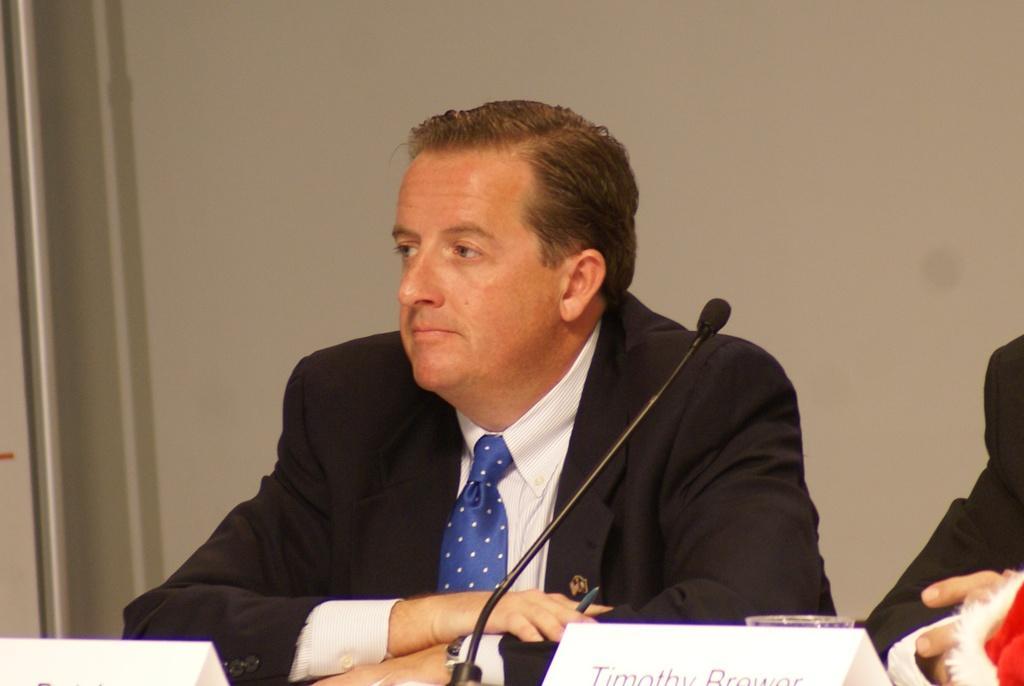Could you give a brief overview of what you see in this image? In the picture we can see a man sitting near the desk, he is in a blazer, tie and shirt and on the desk, we can see a microphone and name board and in the background we can see the wall. 